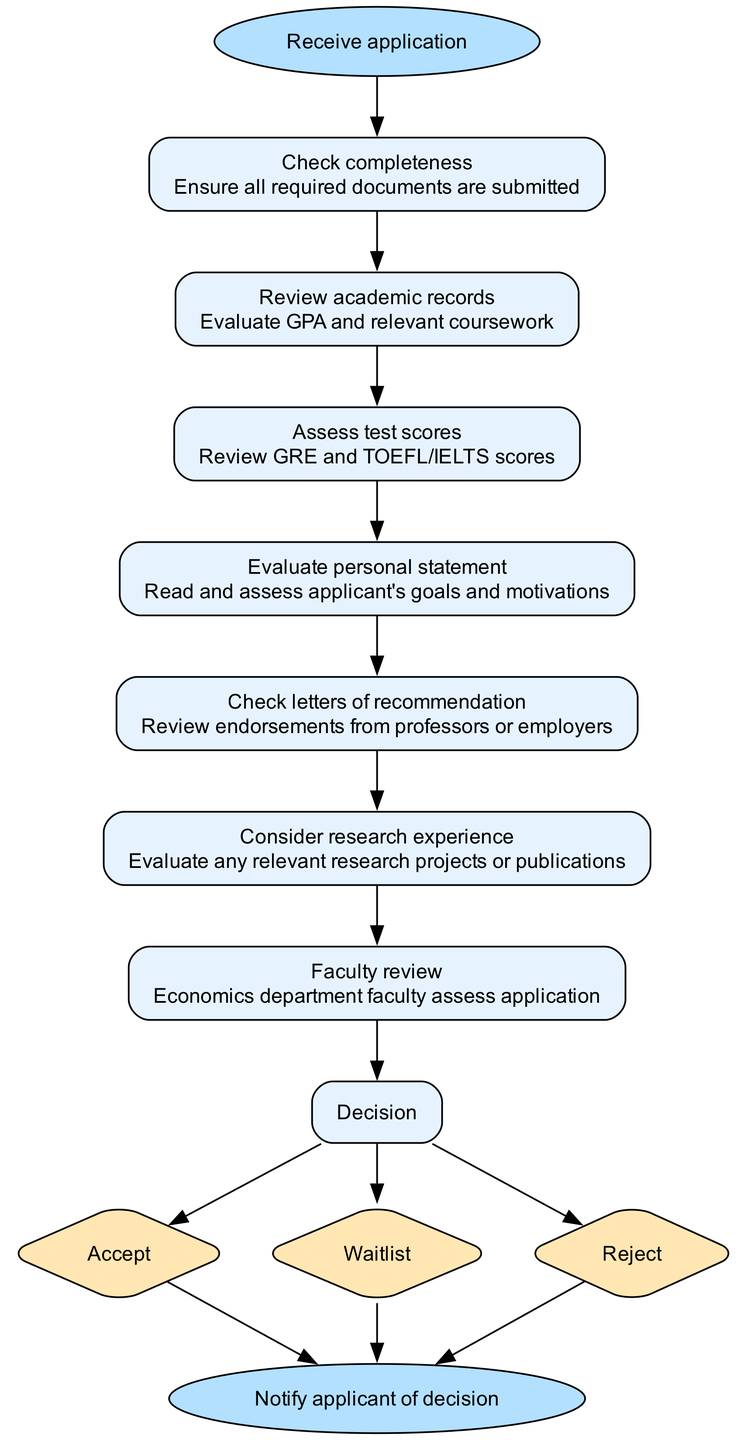What is the first step in the application review process? The first step is indicated in the diagram as "Check completeness", which comes after the initial receipt of the application.
Answer: Check completeness How many steps are involved in the review process? Counting all the steps listed in the diagram, including the decision options, there are seven distinct steps before reaching the final notification to the applicant.
Answer: Seven What does the "Evaluate personal statement" step assess? This step specifically focuses on reading and assessing the applicant's goals and motivations, as described in the flowchart.
Answer: Applicant's goals and motivations Which step comes after "Assess test scores"? Following the "Assess test scores" step in the process is "Evaluate personal statement", as indicated by the directed flow from one step to the next.
Answer: Evaluate personal statement What are the three possible outcomes at the decision stage? At the decision step, the diagram lists three options, which are "Accept," "Waitlist," and "Reject".
Answer: Accept, Waitlist, Reject How does the application review process end? The process concludes with a notification to the applicant regarding their application decision, which is shown as the final step after evaluating all components.
Answer: Notify applicant of decision What role do faculty members play in the review process? Faculty members are responsible for assessing the application during the "Faculty review" step, highlighting their role in evaluating the applicant's suitability for the program.
Answer: Assess application Which step includes an evaluation of relevant research? The "Consider research experience" step is specifically aimed at evaluating any relevant research projects or publications that the applicant may have.
Answer: Consider research experience What document type is assessed in the "Check letters of recommendation" step? In this step, endorsements from professors or employers are reviewed, which are crucial documents for the application.
Answer: Endorsements from professors or employers 